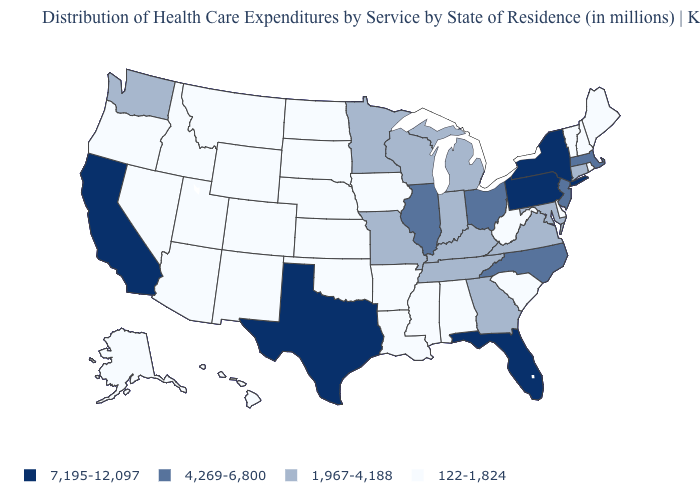Which states hav the highest value in the South?
Give a very brief answer. Florida, Texas. Among the states that border South Carolina , which have the lowest value?
Concise answer only. Georgia. Name the states that have a value in the range 122-1,824?
Answer briefly. Alabama, Alaska, Arizona, Arkansas, Colorado, Delaware, Hawaii, Idaho, Iowa, Kansas, Louisiana, Maine, Mississippi, Montana, Nebraska, Nevada, New Hampshire, New Mexico, North Dakota, Oklahoma, Oregon, Rhode Island, South Carolina, South Dakota, Utah, Vermont, West Virginia, Wyoming. How many symbols are there in the legend?
Write a very short answer. 4. How many symbols are there in the legend?
Keep it brief. 4. Among the states that border Indiana , does Kentucky have the highest value?
Write a very short answer. No. What is the highest value in states that border Iowa?
Write a very short answer. 4,269-6,800. What is the value of Georgia?
Give a very brief answer. 1,967-4,188. Which states have the highest value in the USA?
Short answer required. California, Florida, New York, Pennsylvania, Texas. What is the value of Iowa?
Answer briefly. 122-1,824. Does Florida have a higher value than Pennsylvania?
Short answer required. No. What is the value of North Carolina?
Quick response, please. 4,269-6,800. What is the value of South Carolina?
Keep it brief. 122-1,824. What is the value of Connecticut?
Be succinct. 1,967-4,188. What is the value of Georgia?
Concise answer only. 1,967-4,188. 